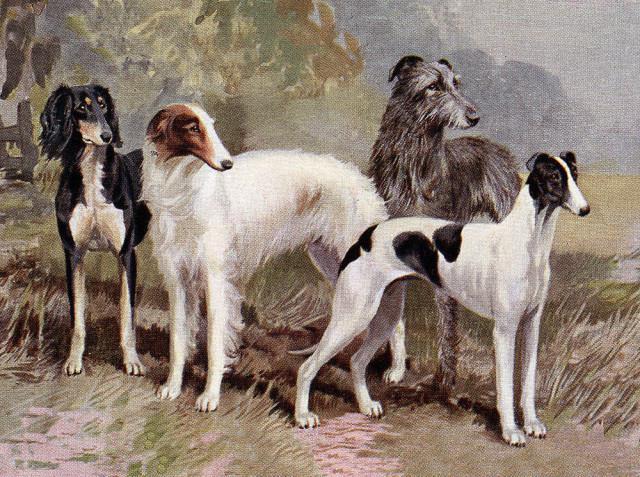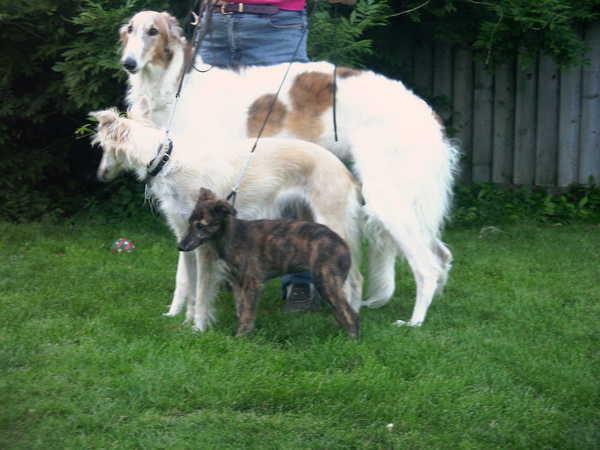The first image is the image on the left, the second image is the image on the right. Given the left and right images, does the statement "there are two dogs standing in the grass with a wall behind them" hold true? Answer yes or no. No. The first image is the image on the left, the second image is the image on the right. Given the left and right images, does the statement "In one image, there are two dogs standing next to each other with their bodies facing the left." hold true? Answer yes or no. No. 